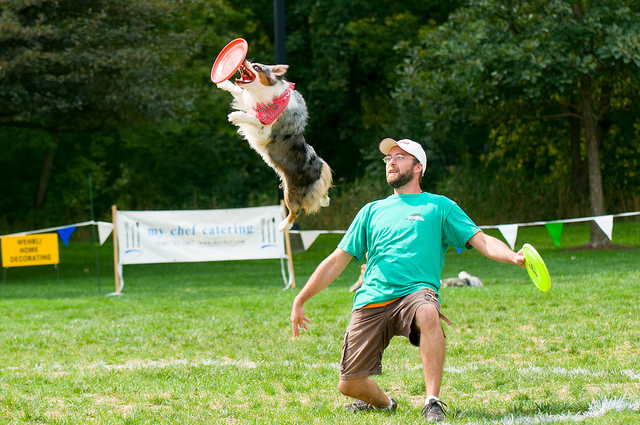Identify and read out the text in this image. chel 